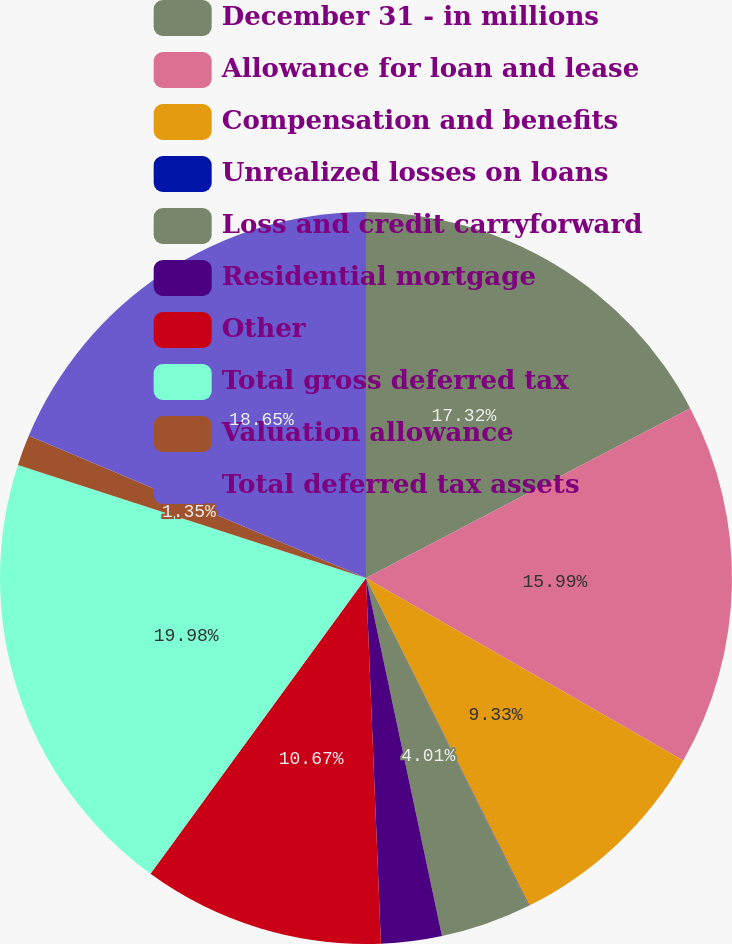Convert chart to OTSL. <chart><loc_0><loc_0><loc_500><loc_500><pie_chart><fcel>December 31 - in millions<fcel>Allowance for loan and lease<fcel>Compensation and benefits<fcel>Unrealized losses on loans<fcel>Loss and credit carryforward<fcel>Residential mortgage<fcel>Other<fcel>Total gross deferred tax<fcel>Valuation allowance<fcel>Total deferred tax assets<nl><fcel>17.32%<fcel>15.99%<fcel>9.33%<fcel>0.02%<fcel>4.01%<fcel>2.68%<fcel>10.67%<fcel>19.98%<fcel>1.35%<fcel>18.65%<nl></chart> 